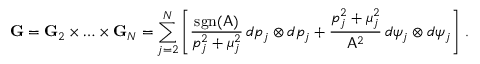Convert formula to latex. <formula><loc_0><loc_0><loc_500><loc_500>G = G _ { 2 } \times \hdots \times G _ { N } = \sum _ { j = 2 } ^ { N } \left [ \frac { s g n ( A ) } { p _ { j } ^ { 2 } + \mu _ { j } ^ { 2 } } \, d p _ { j } \otimes d p _ { j } + \frac { p _ { j } ^ { 2 } + \mu _ { j } ^ { 2 } } { A ^ { 2 } } \, d \psi _ { j } \otimes d \psi _ { j } \right ] \, .</formula> 